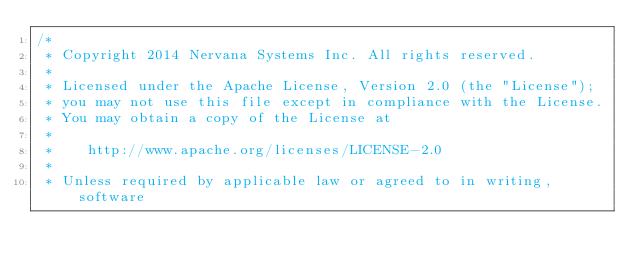<code> <loc_0><loc_0><loc_500><loc_500><_Cuda_>/*
 * Copyright 2014 Nervana Systems Inc. All rights reserved.
 *
 * Licensed under the Apache License, Version 2.0 (the "License");
 * you may not use this file except in compliance with the License.
 * You may obtain a copy of the License at
 * 
 *    http://www.apache.org/licenses/LICENSE-2.0
 * 
 * Unless required by applicable law or agreed to in writing, software</code> 